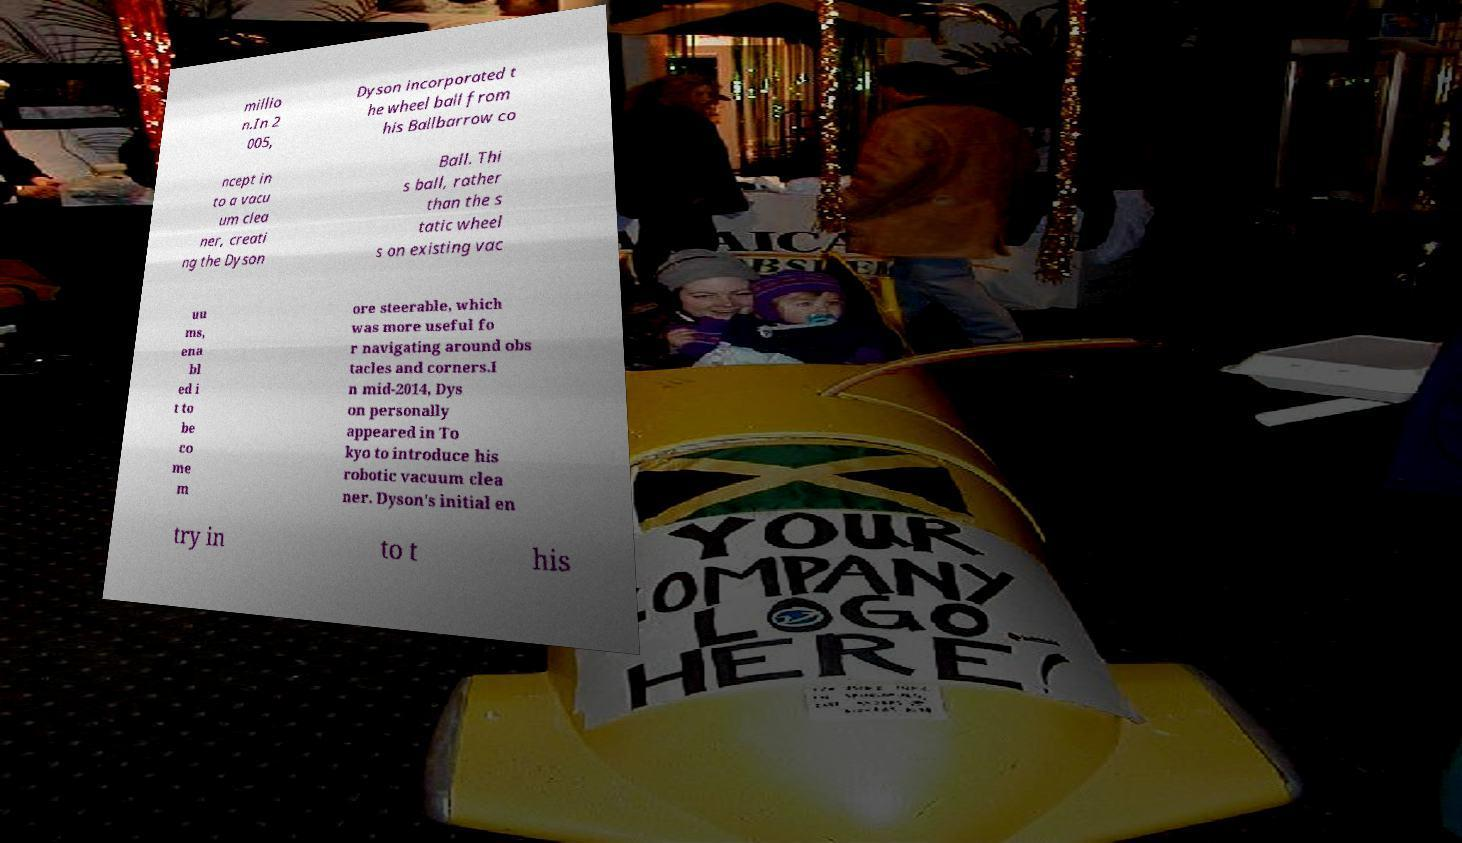Could you extract and type out the text from this image? millio n.In 2 005, Dyson incorporated t he wheel ball from his Ballbarrow co ncept in to a vacu um clea ner, creati ng the Dyson Ball. Thi s ball, rather than the s tatic wheel s on existing vac uu ms, ena bl ed i t to be co me m ore steerable, which was more useful fo r navigating around obs tacles and corners.I n mid-2014, Dys on personally appeared in To kyo to introduce his robotic vacuum clea ner. Dyson's initial en try in to t his 